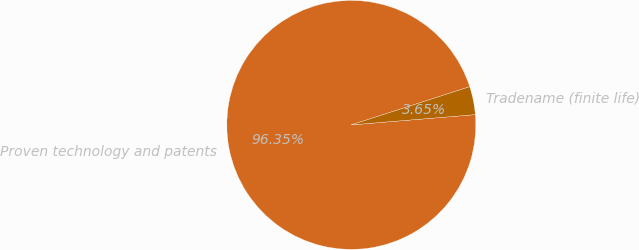<chart> <loc_0><loc_0><loc_500><loc_500><pie_chart><fcel>Proven technology and patents<fcel>Tradename (finite life)<nl><fcel>96.35%<fcel>3.65%<nl></chart> 